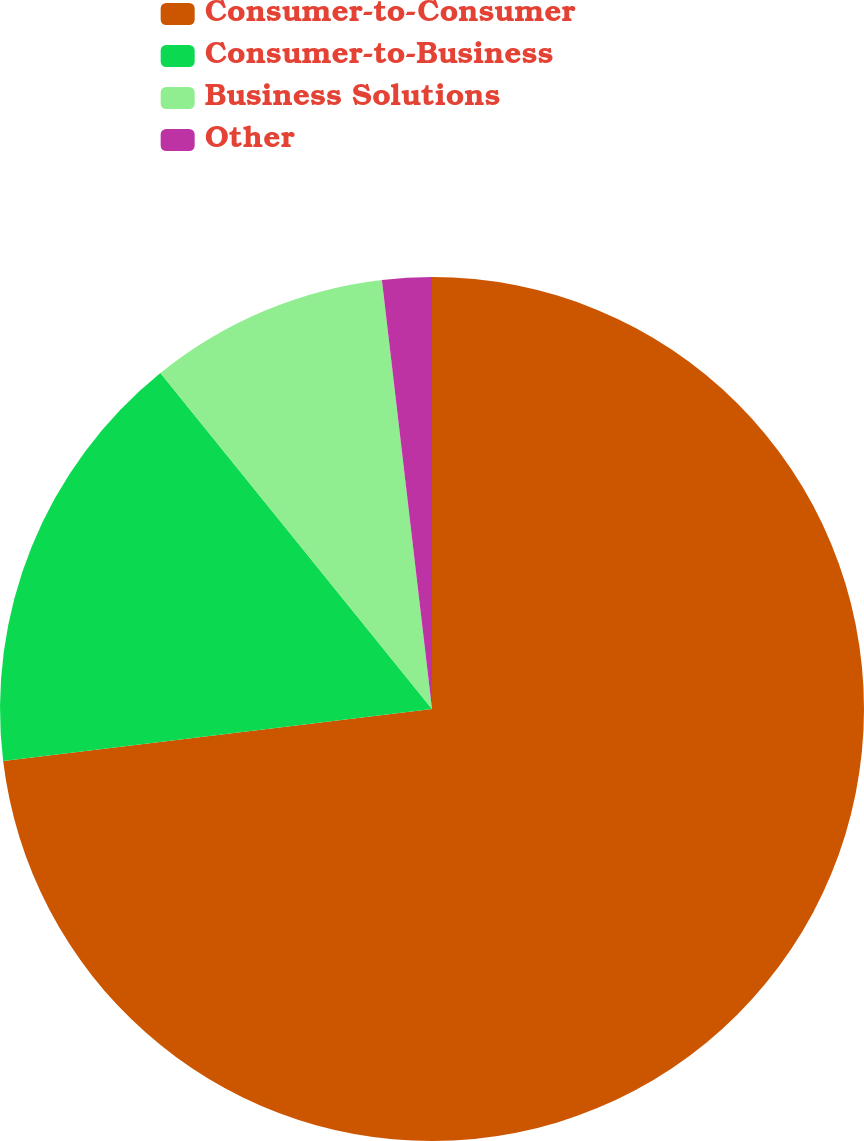Convert chart to OTSL. <chart><loc_0><loc_0><loc_500><loc_500><pie_chart><fcel>Consumer-to-Consumer<fcel>Consumer-to-Business<fcel>Business Solutions<fcel>Other<nl><fcel>73.08%<fcel>16.1%<fcel>8.97%<fcel>1.85%<nl></chart> 